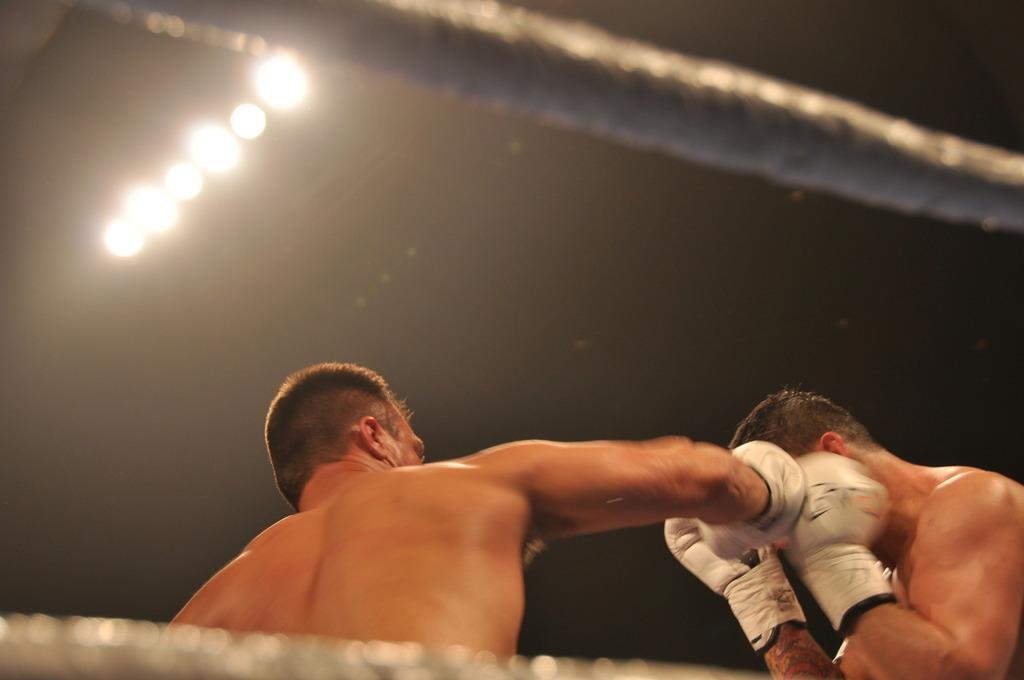How many people are in the image? There are two persons in the image. What are the persons wearing on their hands? The persons are wearing hand gloves. What activity are the persons engaged in? The persons are boxing. What can be seen surrounding the persons? There are ropes visible in the image. What type of illumination is present in the image? There are lights in the image. What type of box is visible in the image? There is no box present in the image; the persons are engaged in boxing as an activity. 